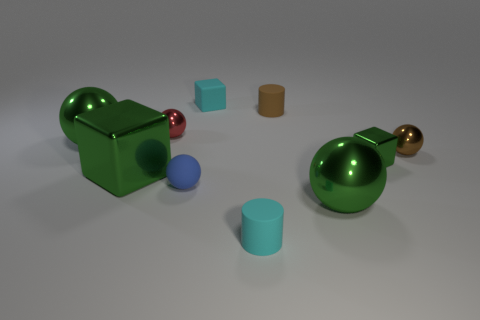Is the number of cyan matte objects behind the big cube the same as the number of big blue metallic spheres?
Make the answer very short. No. How many metallic cylinders are the same size as the blue sphere?
Ensure brevity in your answer.  0. What shape is the matte object that is the same color as the rubber block?
Your answer should be compact. Cylinder. Are there any purple shiny balls?
Offer a terse response. No. Is the shape of the tiny brown metallic thing that is right of the tiny red object the same as the cyan thing behind the red sphere?
Offer a terse response. No. What number of tiny objects are either metal blocks or blue spheres?
Provide a short and direct response. 2. What shape is the small red thing that is the same material as the large block?
Offer a very short reply. Sphere. Is the red metallic thing the same shape as the tiny brown metallic thing?
Your response must be concise. Yes. The tiny metallic block is what color?
Make the answer very short. Green. What number of objects are tiny matte cylinders or tiny matte things?
Your answer should be very brief. 4. 